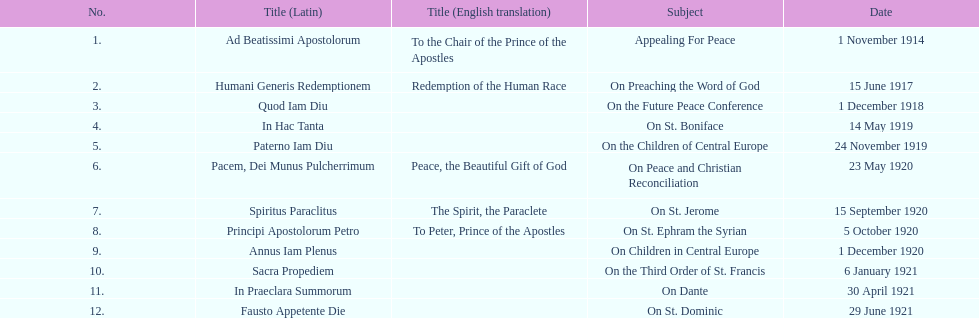Following 1 december 1918, when was the subsequent encyclical? 14 May 1919. 